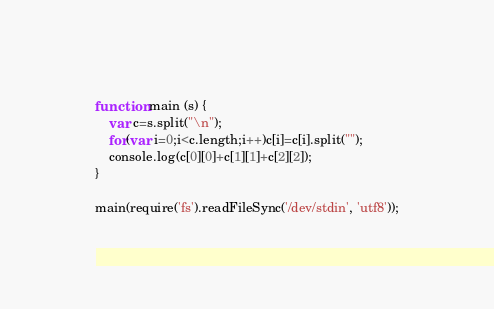<code> <loc_0><loc_0><loc_500><loc_500><_JavaScript_>function main (s) {
	var c=s.split("\n");
	for(var i=0;i<c.length;i++)c[i]=c[i].split("");
	console.log(c[0][0]+c[1][1]+c[2][2]);
}
 
main(require('fs').readFileSync('/dev/stdin', 'utf8'));</code> 